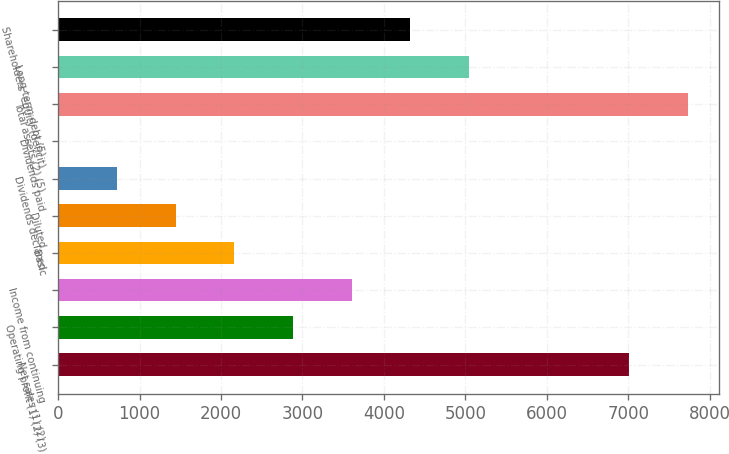Convert chart to OTSL. <chart><loc_0><loc_0><loc_500><loc_500><bar_chart><fcel>Net sales (1) (2)<fcel>Operating profit (1) (2) (3)<fcel>Income from continuing<fcel>Basic<fcel>Diluted<fcel>Dividends declared<fcel>Dividends paid<fcel>Total assets (2) (5)<fcel>Long-term debt (5)<fcel>Shareholders' equity (deficit)<nl><fcel>7006<fcel>2883.41<fcel>3604.18<fcel>2162.64<fcel>1441.87<fcel>721.1<fcel>0.33<fcel>7726.77<fcel>5045.72<fcel>4324.95<nl></chart> 